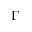<formula> <loc_0><loc_0><loc_500><loc_500>\Gamma</formula> 